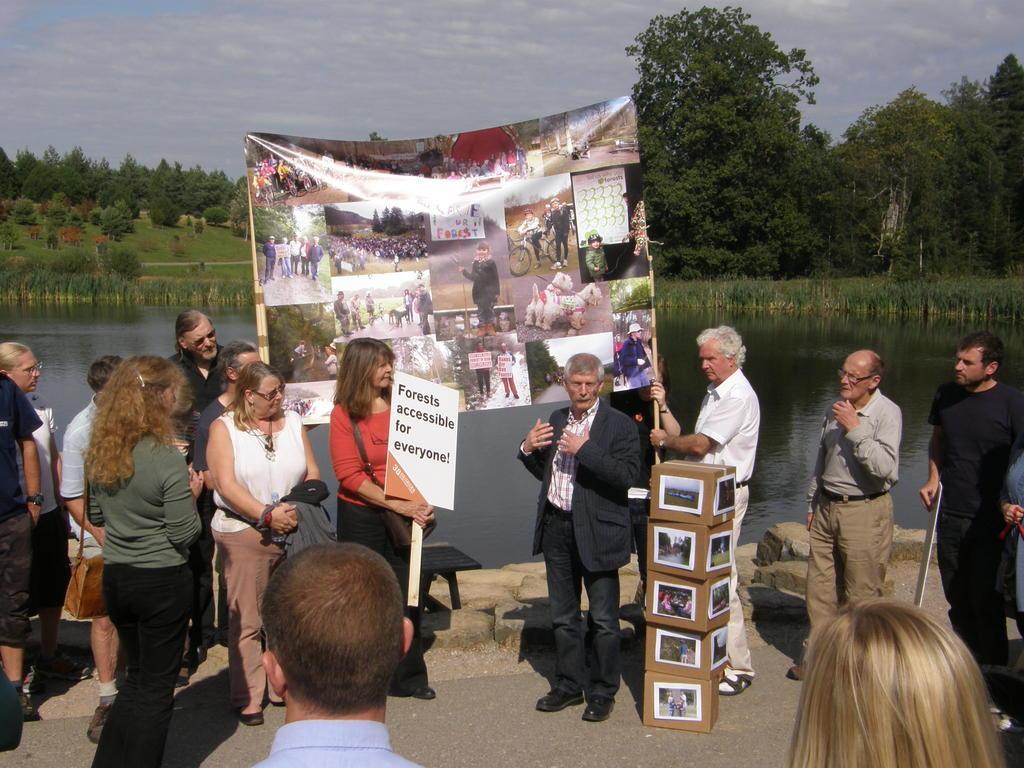Please provide a concise description of this image. In this image I can see the group of people with different color dresses. I can see one person wearing the bag and few people are holding the boards and banners. I can see the cardboard boxes in-between these people. In the banner I can see many people, boards, animals and the trees. In the background I can see the water, many trees and the sky. 